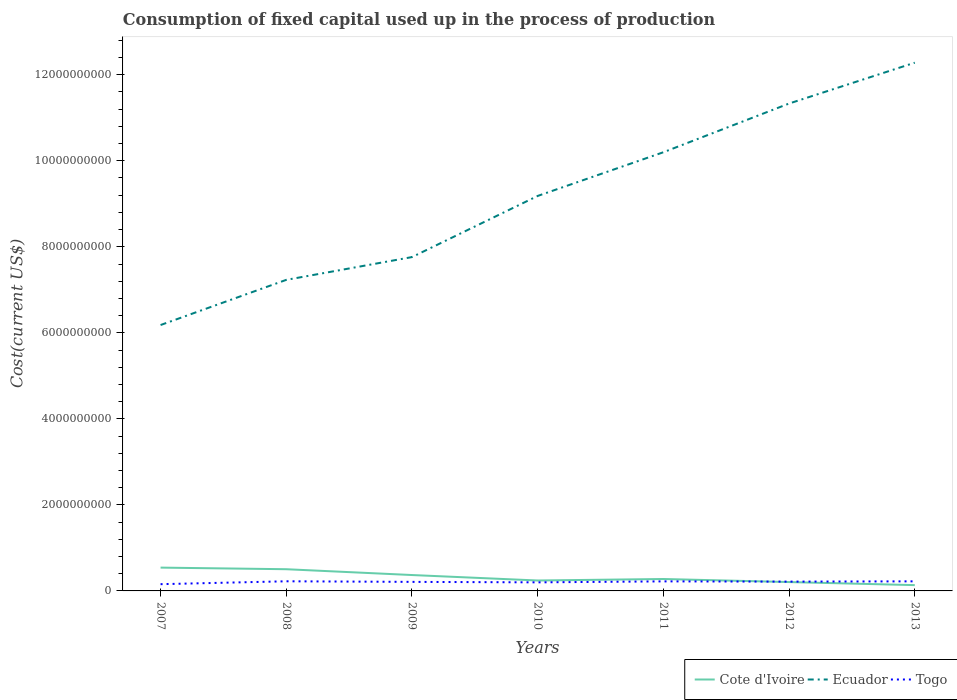How many different coloured lines are there?
Your answer should be very brief. 3. Does the line corresponding to Cote d'Ivoire intersect with the line corresponding to Togo?
Keep it short and to the point. Yes. Across all years, what is the maximum amount consumed in the process of production in Ecuador?
Your answer should be very brief. 6.18e+09. In which year was the amount consumed in the process of production in Ecuador maximum?
Your answer should be very brief. 2007. What is the total amount consumed in the process of production in Ecuador in the graph?
Make the answer very short. -3.57e+09. What is the difference between the highest and the second highest amount consumed in the process of production in Ecuador?
Offer a very short reply. 6.10e+09. Is the amount consumed in the process of production in Ecuador strictly greater than the amount consumed in the process of production in Togo over the years?
Offer a terse response. No. How many lines are there?
Offer a very short reply. 3. How many years are there in the graph?
Offer a terse response. 7. What is the difference between two consecutive major ticks on the Y-axis?
Give a very brief answer. 2.00e+09. Where does the legend appear in the graph?
Your response must be concise. Bottom right. How many legend labels are there?
Your answer should be very brief. 3. How are the legend labels stacked?
Ensure brevity in your answer.  Horizontal. What is the title of the graph?
Make the answer very short. Consumption of fixed capital used up in the process of production. Does "Chad" appear as one of the legend labels in the graph?
Make the answer very short. No. What is the label or title of the X-axis?
Keep it short and to the point. Years. What is the label or title of the Y-axis?
Your answer should be compact. Cost(current US$). What is the Cost(current US$) in Cote d'Ivoire in 2007?
Offer a terse response. 5.42e+08. What is the Cost(current US$) in Ecuador in 2007?
Provide a succinct answer. 6.18e+09. What is the Cost(current US$) of Togo in 2007?
Offer a very short reply. 1.57e+08. What is the Cost(current US$) of Cote d'Ivoire in 2008?
Provide a succinct answer. 5.04e+08. What is the Cost(current US$) in Ecuador in 2008?
Offer a very short reply. 7.23e+09. What is the Cost(current US$) in Togo in 2008?
Provide a succinct answer. 2.24e+08. What is the Cost(current US$) of Cote d'Ivoire in 2009?
Ensure brevity in your answer.  3.70e+08. What is the Cost(current US$) in Ecuador in 2009?
Provide a succinct answer. 7.76e+09. What is the Cost(current US$) in Togo in 2009?
Ensure brevity in your answer.  2.10e+08. What is the Cost(current US$) in Cote d'Ivoire in 2010?
Your answer should be compact. 2.42e+08. What is the Cost(current US$) in Ecuador in 2010?
Make the answer very short. 9.18e+09. What is the Cost(current US$) of Togo in 2010?
Offer a very short reply. 1.99e+08. What is the Cost(current US$) of Cote d'Ivoire in 2011?
Your answer should be compact. 2.77e+08. What is the Cost(current US$) in Ecuador in 2011?
Keep it short and to the point. 1.02e+1. What is the Cost(current US$) of Togo in 2011?
Your answer should be compact. 2.22e+08. What is the Cost(current US$) in Cote d'Ivoire in 2012?
Offer a terse response. 2.06e+08. What is the Cost(current US$) in Ecuador in 2012?
Ensure brevity in your answer.  1.13e+1. What is the Cost(current US$) in Togo in 2012?
Provide a succinct answer. 2.16e+08. What is the Cost(current US$) in Cote d'Ivoire in 2013?
Keep it short and to the point. 1.35e+08. What is the Cost(current US$) of Ecuador in 2013?
Ensure brevity in your answer.  1.23e+1. What is the Cost(current US$) of Togo in 2013?
Offer a very short reply. 2.23e+08. Across all years, what is the maximum Cost(current US$) of Cote d'Ivoire?
Offer a very short reply. 5.42e+08. Across all years, what is the maximum Cost(current US$) of Ecuador?
Offer a terse response. 1.23e+1. Across all years, what is the maximum Cost(current US$) of Togo?
Offer a terse response. 2.24e+08. Across all years, what is the minimum Cost(current US$) in Cote d'Ivoire?
Provide a short and direct response. 1.35e+08. Across all years, what is the minimum Cost(current US$) of Ecuador?
Your answer should be very brief. 6.18e+09. Across all years, what is the minimum Cost(current US$) of Togo?
Provide a short and direct response. 1.57e+08. What is the total Cost(current US$) in Cote d'Ivoire in the graph?
Ensure brevity in your answer.  2.28e+09. What is the total Cost(current US$) of Ecuador in the graph?
Offer a terse response. 6.42e+1. What is the total Cost(current US$) in Togo in the graph?
Offer a terse response. 1.45e+09. What is the difference between the Cost(current US$) of Cote d'Ivoire in 2007 and that in 2008?
Your answer should be very brief. 3.76e+07. What is the difference between the Cost(current US$) in Ecuador in 2007 and that in 2008?
Provide a short and direct response. -1.05e+09. What is the difference between the Cost(current US$) in Togo in 2007 and that in 2008?
Offer a terse response. -6.72e+07. What is the difference between the Cost(current US$) of Cote d'Ivoire in 2007 and that in 2009?
Your answer should be compact. 1.73e+08. What is the difference between the Cost(current US$) of Ecuador in 2007 and that in 2009?
Your answer should be very brief. -1.58e+09. What is the difference between the Cost(current US$) in Togo in 2007 and that in 2009?
Your answer should be very brief. -5.34e+07. What is the difference between the Cost(current US$) of Cote d'Ivoire in 2007 and that in 2010?
Provide a succinct answer. 3.00e+08. What is the difference between the Cost(current US$) in Ecuador in 2007 and that in 2010?
Ensure brevity in your answer.  -3.00e+09. What is the difference between the Cost(current US$) of Togo in 2007 and that in 2010?
Your answer should be compact. -4.23e+07. What is the difference between the Cost(current US$) in Cote d'Ivoire in 2007 and that in 2011?
Ensure brevity in your answer.  2.65e+08. What is the difference between the Cost(current US$) in Ecuador in 2007 and that in 2011?
Your answer should be very brief. -4.02e+09. What is the difference between the Cost(current US$) in Togo in 2007 and that in 2011?
Offer a terse response. -6.53e+07. What is the difference between the Cost(current US$) in Cote d'Ivoire in 2007 and that in 2012?
Provide a short and direct response. 3.36e+08. What is the difference between the Cost(current US$) in Ecuador in 2007 and that in 2012?
Make the answer very short. -5.15e+09. What is the difference between the Cost(current US$) in Togo in 2007 and that in 2012?
Provide a short and direct response. -5.95e+07. What is the difference between the Cost(current US$) in Cote d'Ivoire in 2007 and that in 2013?
Ensure brevity in your answer.  4.07e+08. What is the difference between the Cost(current US$) in Ecuador in 2007 and that in 2013?
Your answer should be compact. -6.10e+09. What is the difference between the Cost(current US$) in Togo in 2007 and that in 2013?
Make the answer very short. -6.59e+07. What is the difference between the Cost(current US$) of Cote d'Ivoire in 2008 and that in 2009?
Ensure brevity in your answer.  1.35e+08. What is the difference between the Cost(current US$) of Ecuador in 2008 and that in 2009?
Keep it short and to the point. -5.29e+08. What is the difference between the Cost(current US$) in Togo in 2008 and that in 2009?
Give a very brief answer. 1.38e+07. What is the difference between the Cost(current US$) in Cote d'Ivoire in 2008 and that in 2010?
Your answer should be compact. 2.62e+08. What is the difference between the Cost(current US$) of Ecuador in 2008 and that in 2010?
Give a very brief answer. -1.95e+09. What is the difference between the Cost(current US$) of Togo in 2008 and that in 2010?
Provide a succinct answer. 2.49e+07. What is the difference between the Cost(current US$) of Cote d'Ivoire in 2008 and that in 2011?
Your answer should be compact. 2.27e+08. What is the difference between the Cost(current US$) in Ecuador in 2008 and that in 2011?
Provide a succinct answer. -2.97e+09. What is the difference between the Cost(current US$) in Togo in 2008 and that in 2011?
Ensure brevity in your answer.  1.91e+06. What is the difference between the Cost(current US$) in Cote d'Ivoire in 2008 and that in 2012?
Offer a very short reply. 2.99e+08. What is the difference between the Cost(current US$) in Ecuador in 2008 and that in 2012?
Make the answer very short. -4.10e+09. What is the difference between the Cost(current US$) in Togo in 2008 and that in 2012?
Keep it short and to the point. 7.71e+06. What is the difference between the Cost(current US$) of Cote d'Ivoire in 2008 and that in 2013?
Offer a very short reply. 3.70e+08. What is the difference between the Cost(current US$) in Ecuador in 2008 and that in 2013?
Ensure brevity in your answer.  -5.05e+09. What is the difference between the Cost(current US$) of Togo in 2008 and that in 2013?
Your answer should be compact. 1.25e+06. What is the difference between the Cost(current US$) of Cote d'Ivoire in 2009 and that in 2010?
Offer a terse response. 1.27e+08. What is the difference between the Cost(current US$) of Ecuador in 2009 and that in 2010?
Give a very brief answer. -1.42e+09. What is the difference between the Cost(current US$) in Togo in 2009 and that in 2010?
Your response must be concise. 1.11e+07. What is the difference between the Cost(current US$) in Cote d'Ivoire in 2009 and that in 2011?
Provide a short and direct response. 9.25e+07. What is the difference between the Cost(current US$) of Ecuador in 2009 and that in 2011?
Provide a succinct answer. -2.44e+09. What is the difference between the Cost(current US$) of Togo in 2009 and that in 2011?
Your answer should be compact. -1.18e+07. What is the difference between the Cost(current US$) of Cote d'Ivoire in 2009 and that in 2012?
Your answer should be compact. 1.64e+08. What is the difference between the Cost(current US$) of Ecuador in 2009 and that in 2012?
Make the answer very short. -3.57e+09. What is the difference between the Cost(current US$) of Togo in 2009 and that in 2012?
Offer a very short reply. -6.04e+06. What is the difference between the Cost(current US$) of Cote d'Ivoire in 2009 and that in 2013?
Give a very brief answer. 2.35e+08. What is the difference between the Cost(current US$) of Ecuador in 2009 and that in 2013?
Your response must be concise. -4.52e+09. What is the difference between the Cost(current US$) in Togo in 2009 and that in 2013?
Offer a very short reply. -1.25e+07. What is the difference between the Cost(current US$) in Cote d'Ivoire in 2010 and that in 2011?
Offer a very short reply. -3.49e+07. What is the difference between the Cost(current US$) of Ecuador in 2010 and that in 2011?
Your answer should be very brief. -1.02e+09. What is the difference between the Cost(current US$) in Togo in 2010 and that in 2011?
Keep it short and to the point. -2.29e+07. What is the difference between the Cost(current US$) in Cote d'Ivoire in 2010 and that in 2012?
Offer a terse response. 3.63e+07. What is the difference between the Cost(current US$) in Ecuador in 2010 and that in 2012?
Provide a succinct answer. -2.15e+09. What is the difference between the Cost(current US$) of Togo in 2010 and that in 2012?
Offer a terse response. -1.71e+07. What is the difference between the Cost(current US$) in Cote d'Ivoire in 2010 and that in 2013?
Offer a terse response. 1.07e+08. What is the difference between the Cost(current US$) of Ecuador in 2010 and that in 2013?
Provide a short and direct response. -3.10e+09. What is the difference between the Cost(current US$) of Togo in 2010 and that in 2013?
Offer a terse response. -2.36e+07. What is the difference between the Cost(current US$) in Cote d'Ivoire in 2011 and that in 2012?
Provide a short and direct response. 7.12e+07. What is the difference between the Cost(current US$) of Ecuador in 2011 and that in 2012?
Keep it short and to the point. -1.13e+09. What is the difference between the Cost(current US$) in Togo in 2011 and that in 2012?
Offer a very short reply. 5.80e+06. What is the difference between the Cost(current US$) of Cote d'Ivoire in 2011 and that in 2013?
Your answer should be compact. 1.42e+08. What is the difference between the Cost(current US$) in Ecuador in 2011 and that in 2013?
Provide a short and direct response. -2.08e+09. What is the difference between the Cost(current US$) of Togo in 2011 and that in 2013?
Your answer should be compact. -6.62e+05. What is the difference between the Cost(current US$) in Cote d'Ivoire in 2012 and that in 2013?
Your answer should be very brief. 7.10e+07. What is the difference between the Cost(current US$) in Ecuador in 2012 and that in 2013?
Keep it short and to the point. -9.49e+08. What is the difference between the Cost(current US$) in Togo in 2012 and that in 2013?
Your answer should be compact. -6.46e+06. What is the difference between the Cost(current US$) of Cote d'Ivoire in 2007 and the Cost(current US$) of Ecuador in 2008?
Make the answer very short. -6.69e+09. What is the difference between the Cost(current US$) in Cote d'Ivoire in 2007 and the Cost(current US$) in Togo in 2008?
Your answer should be very brief. 3.18e+08. What is the difference between the Cost(current US$) in Ecuador in 2007 and the Cost(current US$) in Togo in 2008?
Your answer should be compact. 5.96e+09. What is the difference between the Cost(current US$) in Cote d'Ivoire in 2007 and the Cost(current US$) in Ecuador in 2009?
Give a very brief answer. -7.22e+09. What is the difference between the Cost(current US$) in Cote d'Ivoire in 2007 and the Cost(current US$) in Togo in 2009?
Ensure brevity in your answer.  3.32e+08. What is the difference between the Cost(current US$) of Ecuador in 2007 and the Cost(current US$) of Togo in 2009?
Keep it short and to the point. 5.97e+09. What is the difference between the Cost(current US$) of Cote d'Ivoire in 2007 and the Cost(current US$) of Ecuador in 2010?
Keep it short and to the point. -8.64e+09. What is the difference between the Cost(current US$) of Cote d'Ivoire in 2007 and the Cost(current US$) of Togo in 2010?
Make the answer very short. 3.43e+08. What is the difference between the Cost(current US$) of Ecuador in 2007 and the Cost(current US$) of Togo in 2010?
Offer a very short reply. 5.98e+09. What is the difference between the Cost(current US$) of Cote d'Ivoire in 2007 and the Cost(current US$) of Ecuador in 2011?
Your answer should be compact. -9.66e+09. What is the difference between the Cost(current US$) in Cote d'Ivoire in 2007 and the Cost(current US$) in Togo in 2011?
Your answer should be compact. 3.20e+08. What is the difference between the Cost(current US$) of Ecuador in 2007 and the Cost(current US$) of Togo in 2011?
Your answer should be compact. 5.96e+09. What is the difference between the Cost(current US$) in Cote d'Ivoire in 2007 and the Cost(current US$) in Ecuador in 2012?
Make the answer very short. -1.08e+1. What is the difference between the Cost(current US$) of Cote d'Ivoire in 2007 and the Cost(current US$) of Togo in 2012?
Your answer should be compact. 3.26e+08. What is the difference between the Cost(current US$) of Ecuador in 2007 and the Cost(current US$) of Togo in 2012?
Offer a very short reply. 5.96e+09. What is the difference between the Cost(current US$) of Cote d'Ivoire in 2007 and the Cost(current US$) of Ecuador in 2013?
Ensure brevity in your answer.  -1.17e+1. What is the difference between the Cost(current US$) of Cote d'Ivoire in 2007 and the Cost(current US$) of Togo in 2013?
Your answer should be very brief. 3.19e+08. What is the difference between the Cost(current US$) of Ecuador in 2007 and the Cost(current US$) of Togo in 2013?
Offer a terse response. 5.96e+09. What is the difference between the Cost(current US$) of Cote d'Ivoire in 2008 and the Cost(current US$) of Ecuador in 2009?
Ensure brevity in your answer.  -7.26e+09. What is the difference between the Cost(current US$) in Cote d'Ivoire in 2008 and the Cost(current US$) in Togo in 2009?
Offer a terse response. 2.94e+08. What is the difference between the Cost(current US$) of Ecuador in 2008 and the Cost(current US$) of Togo in 2009?
Make the answer very short. 7.02e+09. What is the difference between the Cost(current US$) of Cote d'Ivoire in 2008 and the Cost(current US$) of Ecuador in 2010?
Provide a short and direct response. -8.68e+09. What is the difference between the Cost(current US$) of Cote d'Ivoire in 2008 and the Cost(current US$) of Togo in 2010?
Provide a succinct answer. 3.05e+08. What is the difference between the Cost(current US$) in Ecuador in 2008 and the Cost(current US$) in Togo in 2010?
Your answer should be very brief. 7.03e+09. What is the difference between the Cost(current US$) of Cote d'Ivoire in 2008 and the Cost(current US$) of Ecuador in 2011?
Offer a very short reply. -9.69e+09. What is the difference between the Cost(current US$) in Cote d'Ivoire in 2008 and the Cost(current US$) in Togo in 2011?
Keep it short and to the point. 2.82e+08. What is the difference between the Cost(current US$) of Ecuador in 2008 and the Cost(current US$) of Togo in 2011?
Ensure brevity in your answer.  7.01e+09. What is the difference between the Cost(current US$) in Cote d'Ivoire in 2008 and the Cost(current US$) in Ecuador in 2012?
Offer a very short reply. -1.08e+1. What is the difference between the Cost(current US$) of Cote d'Ivoire in 2008 and the Cost(current US$) of Togo in 2012?
Give a very brief answer. 2.88e+08. What is the difference between the Cost(current US$) in Ecuador in 2008 and the Cost(current US$) in Togo in 2012?
Keep it short and to the point. 7.02e+09. What is the difference between the Cost(current US$) in Cote d'Ivoire in 2008 and the Cost(current US$) in Ecuador in 2013?
Offer a terse response. -1.18e+1. What is the difference between the Cost(current US$) of Cote d'Ivoire in 2008 and the Cost(current US$) of Togo in 2013?
Ensure brevity in your answer.  2.82e+08. What is the difference between the Cost(current US$) of Ecuador in 2008 and the Cost(current US$) of Togo in 2013?
Ensure brevity in your answer.  7.01e+09. What is the difference between the Cost(current US$) of Cote d'Ivoire in 2009 and the Cost(current US$) of Ecuador in 2010?
Your response must be concise. -8.81e+09. What is the difference between the Cost(current US$) in Cote d'Ivoire in 2009 and the Cost(current US$) in Togo in 2010?
Your answer should be very brief. 1.70e+08. What is the difference between the Cost(current US$) in Ecuador in 2009 and the Cost(current US$) in Togo in 2010?
Provide a succinct answer. 7.56e+09. What is the difference between the Cost(current US$) of Cote d'Ivoire in 2009 and the Cost(current US$) of Ecuador in 2011?
Ensure brevity in your answer.  -9.83e+09. What is the difference between the Cost(current US$) of Cote d'Ivoire in 2009 and the Cost(current US$) of Togo in 2011?
Give a very brief answer. 1.47e+08. What is the difference between the Cost(current US$) in Ecuador in 2009 and the Cost(current US$) in Togo in 2011?
Your answer should be compact. 7.54e+09. What is the difference between the Cost(current US$) in Cote d'Ivoire in 2009 and the Cost(current US$) in Ecuador in 2012?
Your response must be concise. -1.10e+1. What is the difference between the Cost(current US$) in Cote d'Ivoire in 2009 and the Cost(current US$) in Togo in 2012?
Ensure brevity in your answer.  1.53e+08. What is the difference between the Cost(current US$) in Ecuador in 2009 and the Cost(current US$) in Togo in 2012?
Ensure brevity in your answer.  7.54e+09. What is the difference between the Cost(current US$) in Cote d'Ivoire in 2009 and the Cost(current US$) in Ecuador in 2013?
Give a very brief answer. -1.19e+1. What is the difference between the Cost(current US$) of Cote d'Ivoire in 2009 and the Cost(current US$) of Togo in 2013?
Make the answer very short. 1.47e+08. What is the difference between the Cost(current US$) of Ecuador in 2009 and the Cost(current US$) of Togo in 2013?
Make the answer very short. 7.54e+09. What is the difference between the Cost(current US$) of Cote d'Ivoire in 2010 and the Cost(current US$) of Ecuador in 2011?
Your response must be concise. -9.96e+09. What is the difference between the Cost(current US$) of Cote d'Ivoire in 2010 and the Cost(current US$) of Togo in 2011?
Give a very brief answer. 2.01e+07. What is the difference between the Cost(current US$) in Ecuador in 2010 and the Cost(current US$) in Togo in 2011?
Give a very brief answer. 8.96e+09. What is the difference between the Cost(current US$) in Cote d'Ivoire in 2010 and the Cost(current US$) in Ecuador in 2012?
Offer a very short reply. -1.11e+1. What is the difference between the Cost(current US$) in Cote d'Ivoire in 2010 and the Cost(current US$) in Togo in 2012?
Keep it short and to the point. 2.59e+07. What is the difference between the Cost(current US$) of Ecuador in 2010 and the Cost(current US$) of Togo in 2012?
Ensure brevity in your answer.  8.97e+09. What is the difference between the Cost(current US$) of Cote d'Ivoire in 2010 and the Cost(current US$) of Ecuador in 2013?
Provide a succinct answer. -1.20e+1. What is the difference between the Cost(current US$) in Cote d'Ivoire in 2010 and the Cost(current US$) in Togo in 2013?
Give a very brief answer. 1.94e+07. What is the difference between the Cost(current US$) of Ecuador in 2010 and the Cost(current US$) of Togo in 2013?
Give a very brief answer. 8.96e+09. What is the difference between the Cost(current US$) in Cote d'Ivoire in 2011 and the Cost(current US$) in Ecuador in 2012?
Your answer should be compact. -1.11e+1. What is the difference between the Cost(current US$) in Cote d'Ivoire in 2011 and the Cost(current US$) in Togo in 2012?
Provide a succinct answer. 6.08e+07. What is the difference between the Cost(current US$) in Ecuador in 2011 and the Cost(current US$) in Togo in 2012?
Give a very brief answer. 9.98e+09. What is the difference between the Cost(current US$) in Cote d'Ivoire in 2011 and the Cost(current US$) in Ecuador in 2013?
Ensure brevity in your answer.  -1.20e+1. What is the difference between the Cost(current US$) in Cote d'Ivoire in 2011 and the Cost(current US$) in Togo in 2013?
Your response must be concise. 5.43e+07. What is the difference between the Cost(current US$) of Ecuador in 2011 and the Cost(current US$) of Togo in 2013?
Provide a short and direct response. 9.98e+09. What is the difference between the Cost(current US$) in Cote d'Ivoire in 2012 and the Cost(current US$) in Ecuador in 2013?
Keep it short and to the point. -1.21e+1. What is the difference between the Cost(current US$) in Cote d'Ivoire in 2012 and the Cost(current US$) in Togo in 2013?
Provide a short and direct response. -1.69e+07. What is the difference between the Cost(current US$) of Ecuador in 2012 and the Cost(current US$) of Togo in 2013?
Provide a short and direct response. 1.11e+1. What is the average Cost(current US$) in Cote d'Ivoire per year?
Provide a succinct answer. 3.25e+08. What is the average Cost(current US$) of Ecuador per year?
Give a very brief answer. 9.17e+09. What is the average Cost(current US$) in Togo per year?
Offer a terse response. 2.07e+08. In the year 2007, what is the difference between the Cost(current US$) in Cote d'Ivoire and Cost(current US$) in Ecuador?
Offer a very short reply. -5.64e+09. In the year 2007, what is the difference between the Cost(current US$) in Cote d'Ivoire and Cost(current US$) in Togo?
Your answer should be very brief. 3.85e+08. In the year 2007, what is the difference between the Cost(current US$) of Ecuador and Cost(current US$) of Togo?
Offer a very short reply. 6.02e+09. In the year 2008, what is the difference between the Cost(current US$) of Cote d'Ivoire and Cost(current US$) of Ecuador?
Your answer should be very brief. -6.73e+09. In the year 2008, what is the difference between the Cost(current US$) of Cote d'Ivoire and Cost(current US$) of Togo?
Give a very brief answer. 2.80e+08. In the year 2008, what is the difference between the Cost(current US$) in Ecuador and Cost(current US$) in Togo?
Keep it short and to the point. 7.01e+09. In the year 2009, what is the difference between the Cost(current US$) in Cote d'Ivoire and Cost(current US$) in Ecuador?
Give a very brief answer. -7.39e+09. In the year 2009, what is the difference between the Cost(current US$) of Cote d'Ivoire and Cost(current US$) of Togo?
Offer a very short reply. 1.59e+08. In the year 2009, what is the difference between the Cost(current US$) in Ecuador and Cost(current US$) in Togo?
Your answer should be very brief. 7.55e+09. In the year 2010, what is the difference between the Cost(current US$) in Cote d'Ivoire and Cost(current US$) in Ecuador?
Your answer should be compact. -8.94e+09. In the year 2010, what is the difference between the Cost(current US$) of Cote d'Ivoire and Cost(current US$) of Togo?
Your answer should be compact. 4.30e+07. In the year 2010, what is the difference between the Cost(current US$) of Ecuador and Cost(current US$) of Togo?
Provide a short and direct response. 8.98e+09. In the year 2011, what is the difference between the Cost(current US$) in Cote d'Ivoire and Cost(current US$) in Ecuador?
Provide a short and direct response. -9.92e+09. In the year 2011, what is the difference between the Cost(current US$) of Cote d'Ivoire and Cost(current US$) of Togo?
Your answer should be compact. 5.50e+07. In the year 2011, what is the difference between the Cost(current US$) in Ecuador and Cost(current US$) in Togo?
Your answer should be compact. 9.98e+09. In the year 2012, what is the difference between the Cost(current US$) of Cote d'Ivoire and Cost(current US$) of Ecuador?
Provide a short and direct response. -1.11e+1. In the year 2012, what is the difference between the Cost(current US$) of Cote d'Ivoire and Cost(current US$) of Togo?
Your answer should be very brief. -1.04e+07. In the year 2012, what is the difference between the Cost(current US$) in Ecuador and Cost(current US$) in Togo?
Offer a very short reply. 1.11e+1. In the year 2013, what is the difference between the Cost(current US$) in Cote d'Ivoire and Cost(current US$) in Ecuador?
Your answer should be compact. -1.21e+1. In the year 2013, what is the difference between the Cost(current US$) of Cote d'Ivoire and Cost(current US$) of Togo?
Ensure brevity in your answer.  -8.79e+07. In the year 2013, what is the difference between the Cost(current US$) in Ecuador and Cost(current US$) in Togo?
Give a very brief answer. 1.21e+1. What is the ratio of the Cost(current US$) in Cote d'Ivoire in 2007 to that in 2008?
Make the answer very short. 1.07. What is the ratio of the Cost(current US$) in Ecuador in 2007 to that in 2008?
Make the answer very short. 0.85. What is the ratio of the Cost(current US$) of Togo in 2007 to that in 2008?
Your answer should be compact. 0.7. What is the ratio of the Cost(current US$) of Cote d'Ivoire in 2007 to that in 2009?
Offer a terse response. 1.47. What is the ratio of the Cost(current US$) in Ecuador in 2007 to that in 2009?
Your response must be concise. 0.8. What is the ratio of the Cost(current US$) of Togo in 2007 to that in 2009?
Your answer should be compact. 0.75. What is the ratio of the Cost(current US$) in Cote d'Ivoire in 2007 to that in 2010?
Ensure brevity in your answer.  2.24. What is the ratio of the Cost(current US$) of Ecuador in 2007 to that in 2010?
Your answer should be very brief. 0.67. What is the ratio of the Cost(current US$) in Togo in 2007 to that in 2010?
Your response must be concise. 0.79. What is the ratio of the Cost(current US$) of Cote d'Ivoire in 2007 to that in 2011?
Give a very brief answer. 1.96. What is the ratio of the Cost(current US$) in Ecuador in 2007 to that in 2011?
Your answer should be compact. 0.61. What is the ratio of the Cost(current US$) of Togo in 2007 to that in 2011?
Your answer should be compact. 0.71. What is the ratio of the Cost(current US$) of Cote d'Ivoire in 2007 to that in 2012?
Your answer should be very brief. 2.63. What is the ratio of the Cost(current US$) in Ecuador in 2007 to that in 2012?
Provide a short and direct response. 0.55. What is the ratio of the Cost(current US$) in Togo in 2007 to that in 2012?
Provide a succinct answer. 0.72. What is the ratio of the Cost(current US$) of Cote d'Ivoire in 2007 to that in 2013?
Give a very brief answer. 4.02. What is the ratio of the Cost(current US$) of Ecuador in 2007 to that in 2013?
Your answer should be very brief. 0.5. What is the ratio of the Cost(current US$) of Togo in 2007 to that in 2013?
Your answer should be very brief. 0.7. What is the ratio of the Cost(current US$) in Cote d'Ivoire in 2008 to that in 2009?
Give a very brief answer. 1.37. What is the ratio of the Cost(current US$) in Ecuador in 2008 to that in 2009?
Give a very brief answer. 0.93. What is the ratio of the Cost(current US$) in Togo in 2008 to that in 2009?
Provide a succinct answer. 1.07. What is the ratio of the Cost(current US$) in Cote d'Ivoire in 2008 to that in 2010?
Your response must be concise. 2.08. What is the ratio of the Cost(current US$) of Ecuador in 2008 to that in 2010?
Make the answer very short. 0.79. What is the ratio of the Cost(current US$) in Togo in 2008 to that in 2010?
Your answer should be very brief. 1.12. What is the ratio of the Cost(current US$) of Cote d'Ivoire in 2008 to that in 2011?
Make the answer very short. 1.82. What is the ratio of the Cost(current US$) of Ecuador in 2008 to that in 2011?
Give a very brief answer. 0.71. What is the ratio of the Cost(current US$) of Togo in 2008 to that in 2011?
Your answer should be compact. 1.01. What is the ratio of the Cost(current US$) of Cote d'Ivoire in 2008 to that in 2012?
Offer a very short reply. 2.45. What is the ratio of the Cost(current US$) of Ecuador in 2008 to that in 2012?
Offer a very short reply. 0.64. What is the ratio of the Cost(current US$) in Togo in 2008 to that in 2012?
Keep it short and to the point. 1.04. What is the ratio of the Cost(current US$) of Cote d'Ivoire in 2008 to that in 2013?
Ensure brevity in your answer.  3.74. What is the ratio of the Cost(current US$) of Ecuador in 2008 to that in 2013?
Your answer should be very brief. 0.59. What is the ratio of the Cost(current US$) of Togo in 2008 to that in 2013?
Provide a short and direct response. 1.01. What is the ratio of the Cost(current US$) of Cote d'Ivoire in 2009 to that in 2010?
Offer a terse response. 1.53. What is the ratio of the Cost(current US$) in Ecuador in 2009 to that in 2010?
Your answer should be very brief. 0.85. What is the ratio of the Cost(current US$) in Togo in 2009 to that in 2010?
Keep it short and to the point. 1.06. What is the ratio of the Cost(current US$) in Cote d'Ivoire in 2009 to that in 2011?
Offer a very short reply. 1.33. What is the ratio of the Cost(current US$) of Ecuador in 2009 to that in 2011?
Make the answer very short. 0.76. What is the ratio of the Cost(current US$) of Togo in 2009 to that in 2011?
Your answer should be very brief. 0.95. What is the ratio of the Cost(current US$) of Cote d'Ivoire in 2009 to that in 2012?
Your response must be concise. 1.8. What is the ratio of the Cost(current US$) in Ecuador in 2009 to that in 2012?
Keep it short and to the point. 0.68. What is the ratio of the Cost(current US$) in Togo in 2009 to that in 2012?
Offer a very short reply. 0.97. What is the ratio of the Cost(current US$) in Cote d'Ivoire in 2009 to that in 2013?
Your response must be concise. 2.74. What is the ratio of the Cost(current US$) of Ecuador in 2009 to that in 2013?
Offer a terse response. 0.63. What is the ratio of the Cost(current US$) in Togo in 2009 to that in 2013?
Ensure brevity in your answer.  0.94. What is the ratio of the Cost(current US$) of Cote d'Ivoire in 2010 to that in 2011?
Ensure brevity in your answer.  0.87. What is the ratio of the Cost(current US$) of Ecuador in 2010 to that in 2011?
Your response must be concise. 0.9. What is the ratio of the Cost(current US$) of Togo in 2010 to that in 2011?
Your answer should be very brief. 0.9. What is the ratio of the Cost(current US$) of Cote d'Ivoire in 2010 to that in 2012?
Give a very brief answer. 1.18. What is the ratio of the Cost(current US$) in Ecuador in 2010 to that in 2012?
Your answer should be very brief. 0.81. What is the ratio of the Cost(current US$) of Togo in 2010 to that in 2012?
Ensure brevity in your answer.  0.92. What is the ratio of the Cost(current US$) in Cote d'Ivoire in 2010 to that in 2013?
Make the answer very short. 1.8. What is the ratio of the Cost(current US$) in Ecuador in 2010 to that in 2013?
Ensure brevity in your answer.  0.75. What is the ratio of the Cost(current US$) of Togo in 2010 to that in 2013?
Your answer should be very brief. 0.89. What is the ratio of the Cost(current US$) in Cote d'Ivoire in 2011 to that in 2012?
Your answer should be very brief. 1.35. What is the ratio of the Cost(current US$) in Togo in 2011 to that in 2012?
Keep it short and to the point. 1.03. What is the ratio of the Cost(current US$) of Cote d'Ivoire in 2011 to that in 2013?
Provide a short and direct response. 2.05. What is the ratio of the Cost(current US$) in Ecuador in 2011 to that in 2013?
Ensure brevity in your answer.  0.83. What is the ratio of the Cost(current US$) of Togo in 2011 to that in 2013?
Provide a succinct answer. 1. What is the ratio of the Cost(current US$) in Cote d'Ivoire in 2012 to that in 2013?
Provide a short and direct response. 1.53. What is the ratio of the Cost(current US$) of Ecuador in 2012 to that in 2013?
Offer a very short reply. 0.92. What is the difference between the highest and the second highest Cost(current US$) of Cote d'Ivoire?
Offer a very short reply. 3.76e+07. What is the difference between the highest and the second highest Cost(current US$) in Ecuador?
Offer a terse response. 9.49e+08. What is the difference between the highest and the second highest Cost(current US$) in Togo?
Provide a succinct answer. 1.25e+06. What is the difference between the highest and the lowest Cost(current US$) in Cote d'Ivoire?
Your answer should be very brief. 4.07e+08. What is the difference between the highest and the lowest Cost(current US$) of Ecuador?
Give a very brief answer. 6.10e+09. What is the difference between the highest and the lowest Cost(current US$) in Togo?
Provide a succinct answer. 6.72e+07. 